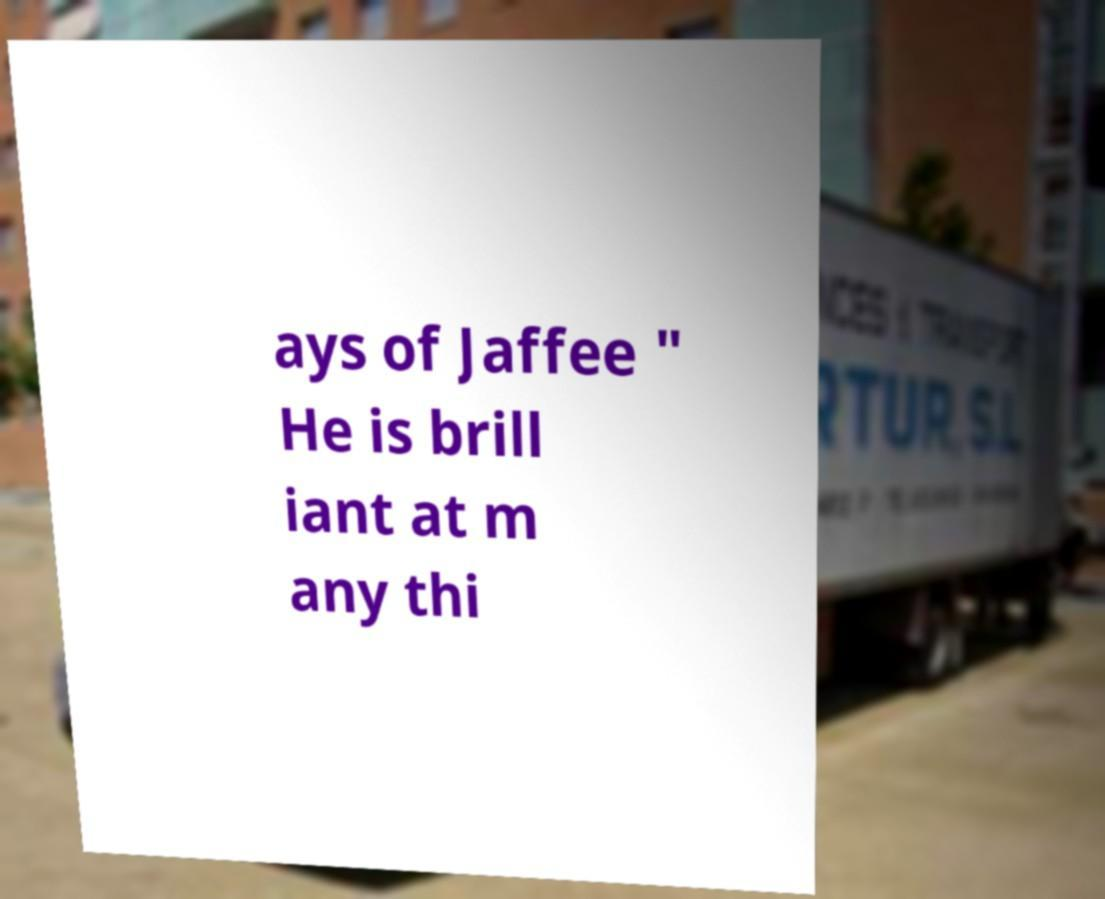Could you extract and type out the text from this image? ays of Jaffee " He is brill iant at m any thi 